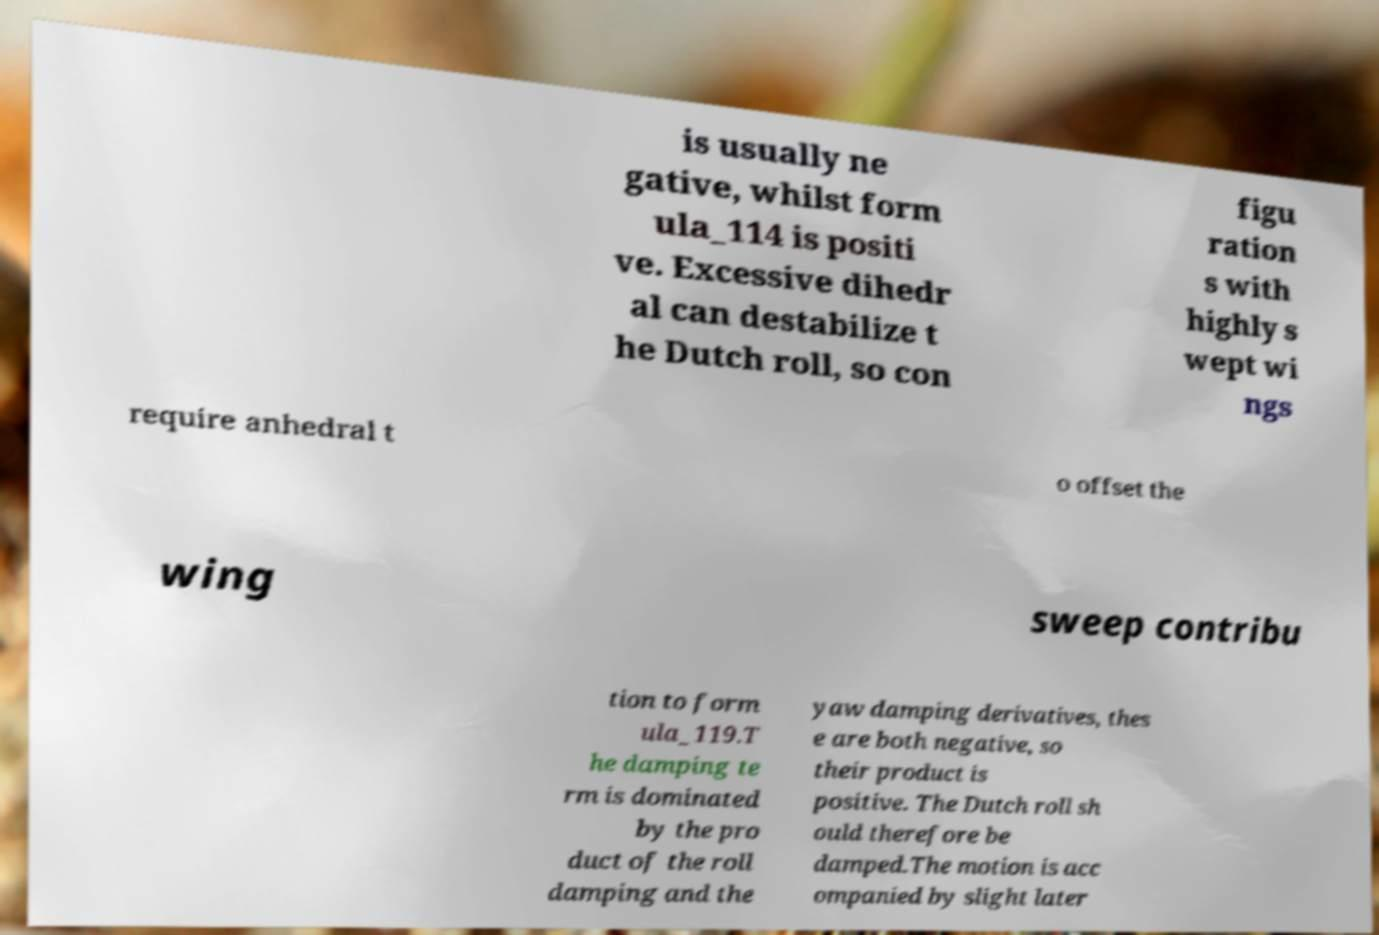Could you extract and type out the text from this image? is usually ne gative, whilst form ula_114 is positi ve. Excessive dihedr al can destabilize t he Dutch roll, so con figu ration s with highly s wept wi ngs require anhedral t o offset the wing sweep contribu tion to form ula_119.T he damping te rm is dominated by the pro duct of the roll damping and the yaw damping derivatives, thes e are both negative, so their product is positive. The Dutch roll sh ould therefore be damped.The motion is acc ompanied by slight later 